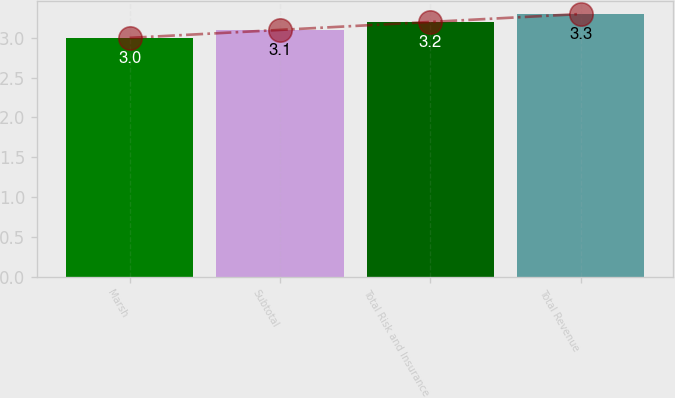Convert chart. <chart><loc_0><loc_0><loc_500><loc_500><bar_chart><fcel>Marsh<fcel>Subtotal<fcel>Total Risk and Insurance<fcel>Total Revenue<nl><fcel>3<fcel>3.1<fcel>3.2<fcel>3.3<nl></chart> 